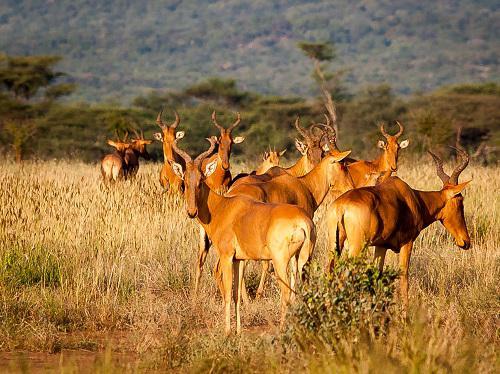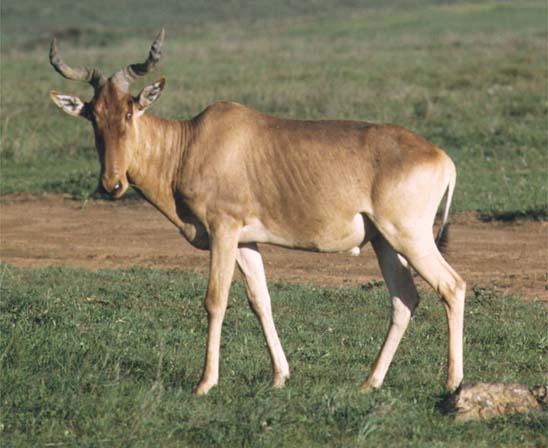The first image is the image on the left, the second image is the image on the right. For the images displayed, is the sentence "The right image contains one horned animal with its body turned rightward, and the left image contains at least five horned animals." factually correct? Answer yes or no. No. The first image is the image on the left, the second image is the image on the right. Assess this claim about the two images: "There are more then six of these antelope-like creatures.". Correct or not? Answer yes or no. Yes. 